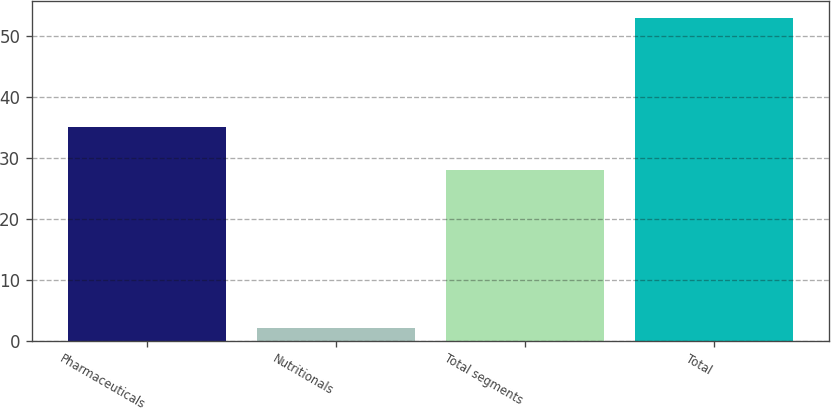Convert chart. <chart><loc_0><loc_0><loc_500><loc_500><bar_chart><fcel>Pharmaceuticals<fcel>Nutritionals<fcel>Total segments<fcel>Total<nl><fcel>35<fcel>2<fcel>28<fcel>53<nl></chart> 